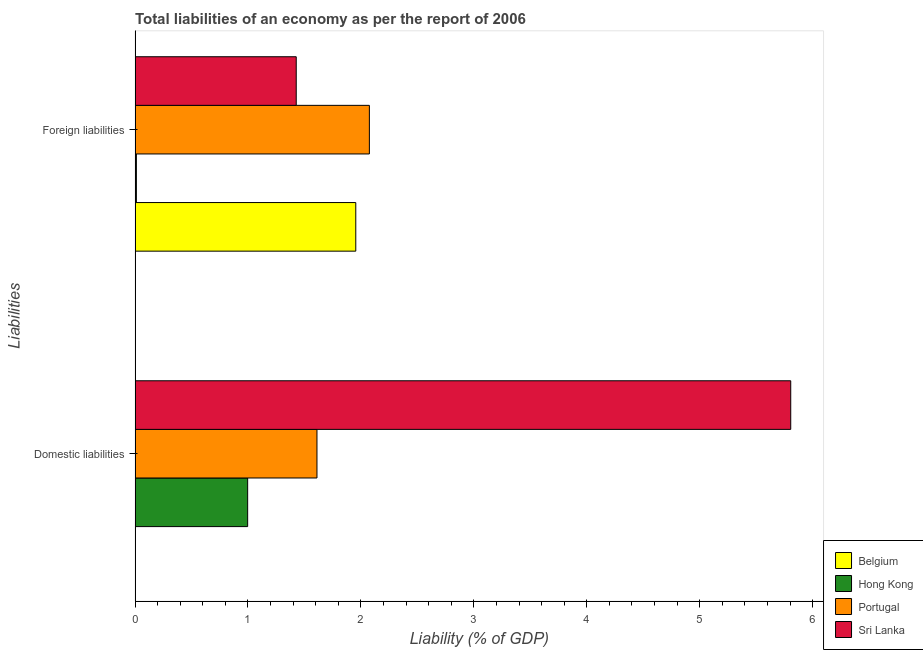How many groups of bars are there?
Provide a succinct answer. 2. Are the number of bars per tick equal to the number of legend labels?
Your answer should be compact. No. Are the number of bars on each tick of the Y-axis equal?
Your response must be concise. No. How many bars are there on the 2nd tick from the bottom?
Give a very brief answer. 4. What is the label of the 1st group of bars from the top?
Provide a short and direct response. Foreign liabilities. What is the incurrence of foreign liabilities in Sri Lanka?
Keep it short and to the point. 1.43. Across all countries, what is the maximum incurrence of domestic liabilities?
Offer a terse response. 5.81. In which country was the incurrence of foreign liabilities maximum?
Make the answer very short. Portugal. What is the total incurrence of foreign liabilities in the graph?
Provide a succinct answer. 5.47. What is the difference between the incurrence of foreign liabilities in Belgium and that in Hong Kong?
Your answer should be compact. 1.94. What is the difference between the incurrence of foreign liabilities in Portugal and the incurrence of domestic liabilities in Belgium?
Give a very brief answer. 2.07. What is the average incurrence of domestic liabilities per country?
Provide a short and direct response. 2.1. What is the difference between the incurrence of domestic liabilities and incurrence of foreign liabilities in Sri Lanka?
Offer a terse response. 4.38. In how many countries, is the incurrence of domestic liabilities greater than 5.2 %?
Offer a terse response. 1. What is the ratio of the incurrence of foreign liabilities in Sri Lanka to that in Hong Kong?
Your answer should be very brief. 123.3. Is the incurrence of foreign liabilities in Belgium less than that in Hong Kong?
Provide a succinct answer. No. What is the difference between two consecutive major ticks on the X-axis?
Provide a short and direct response. 1. Does the graph contain any zero values?
Your answer should be very brief. Yes. How are the legend labels stacked?
Make the answer very short. Vertical. What is the title of the graph?
Offer a terse response. Total liabilities of an economy as per the report of 2006. Does "Tajikistan" appear as one of the legend labels in the graph?
Your answer should be compact. No. What is the label or title of the X-axis?
Offer a very short reply. Liability (% of GDP). What is the label or title of the Y-axis?
Your response must be concise. Liabilities. What is the Liability (% of GDP) of Belgium in Domestic liabilities?
Your answer should be compact. 0. What is the Liability (% of GDP) in Hong Kong in Domestic liabilities?
Ensure brevity in your answer.  1. What is the Liability (% of GDP) of Portugal in Domestic liabilities?
Ensure brevity in your answer.  1.61. What is the Liability (% of GDP) of Sri Lanka in Domestic liabilities?
Provide a succinct answer. 5.81. What is the Liability (% of GDP) in Belgium in Foreign liabilities?
Your answer should be compact. 1.95. What is the Liability (% of GDP) in Hong Kong in Foreign liabilities?
Your answer should be compact. 0.01. What is the Liability (% of GDP) in Portugal in Foreign liabilities?
Provide a succinct answer. 2.07. What is the Liability (% of GDP) in Sri Lanka in Foreign liabilities?
Make the answer very short. 1.43. Across all Liabilities, what is the maximum Liability (% of GDP) of Belgium?
Offer a very short reply. 1.95. Across all Liabilities, what is the maximum Liability (% of GDP) in Hong Kong?
Offer a terse response. 1. Across all Liabilities, what is the maximum Liability (% of GDP) in Portugal?
Offer a very short reply. 2.07. Across all Liabilities, what is the maximum Liability (% of GDP) of Sri Lanka?
Make the answer very short. 5.81. Across all Liabilities, what is the minimum Liability (% of GDP) of Belgium?
Offer a very short reply. 0. Across all Liabilities, what is the minimum Liability (% of GDP) in Hong Kong?
Make the answer very short. 0.01. Across all Liabilities, what is the minimum Liability (% of GDP) of Portugal?
Your answer should be compact. 1.61. Across all Liabilities, what is the minimum Liability (% of GDP) of Sri Lanka?
Keep it short and to the point. 1.43. What is the total Liability (% of GDP) of Belgium in the graph?
Provide a succinct answer. 1.95. What is the total Liability (% of GDP) of Hong Kong in the graph?
Offer a very short reply. 1.01. What is the total Liability (% of GDP) in Portugal in the graph?
Offer a very short reply. 3.69. What is the total Liability (% of GDP) of Sri Lanka in the graph?
Your response must be concise. 7.23. What is the difference between the Liability (% of GDP) in Hong Kong in Domestic liabilities and that in Foreign liabilities?
Provide a short and direct response. 0.99. What is the difference between the Liability (% of GDP) of Portugal in Domestic liabilities and that in Foreign liabilities?
Make the answer very short. -0.46. What is the difference between the Liability (% of GDP) of Sri Lanka in Domestic liabilities and that in Foreign liabilities?
Ensure brevity in your answer.  4.38. What is the difference between the Liability (% of GDP) in Hong Kong in Domestic liabilities and the Liability (% of GDP) in Portugal in Foreign liabilities?
Provide a succinct answer. -1.08. What is the difference between the Liability (% of GDP) of Hong Kong in Domestic liabilities and the Liability (% of GDP) of Sri Lanka in Foreign liabilities?
Your response must be concise. -0.43. What is the difference between the Liability (% of GDP) of Portugal in Domestic liabilities and the Liability (% of GDP) of Sri Lanka in Foreign liabilities?
Keep it short and to the point. 0.18. What is the average Liability (% of GDP) of Belgium per Liabilities?
Keep it short and to the point. 0.98. What is the average Liability (% of GDP) in Hong Kong per Liabilities?
Your answer should be very brief. 0.5. What is the average Liability (% of GDP) of Portugal per Liabilities?
Your answer should be very brief. 1.84. What is the average Liability (% of GDP) in Sri Lanka per Liabilities?
Offer a very short reply. 3.62. What is the difference between the Liability (% of GDP) of Hong Kong and Liability (% of GDP) of Portugal in Domestic liabilities?
Give a very brief answer. -0.61. What is the difference between the Liability (% of GDP) of Hong Kong and Liability (% of GDP) of Sri Lanka in Domestic liabilities?
Give a very brief answer. -4.81. What is the difference between the Liability (% of GDP) of Portugal and Liability (% of GDP) of Sri Lanka in Domestic liabilities?
Your answer should be compact. -4.2. What is the difference between the Liability (% of GDP) in Belgium and Liability (% of GDP) in Hong Kong in Foreign liabilities?
Give a very brief answer. 1.94. What is the difference between the Liability (% of GDP) in Belgium and Liability (% of GDP) in Portugal in Foreign liabilities?
Your answer should be compact. -0.12. What is the difference between the Liability (% of GDP) in Belgium and Liability (% of GDP) in Sri Lanka in Foreign liabilities?
Offer a terse response. 0.53. What is the difference between the Liability (% of GDP) of Hong Kong and Liability (% of GDP) of Portugal in Foreign liabilities?
Your response must be concise. -2.06. What is the difference between the Liability (% of GDP) of Hong Kong and Liability (% of GDP) of Sri Lanka in Foreign liabilities?
Your answer should be very brief. -1.42. What is the difference between the Liability (% of GDP) of Portugal and Liability (% of GDP) of Sri Lanka in Foreign liabilities?
Offer a terse response. 0.65. What is the ratio of the Liability (% of GDP) of Hong Kong in Domestic liabilities to that in Foreign liabilities?
Offer a terse response. 86.14. What is the ratio of the Liability (% of GDP) of Portugal in Domestic liabilities to that in Foreign liabilities?
Give a very brief answer. 0.78. What is the ratio of the Liability (% of GDP) in Sri Lanka in Domestic liabilities to that in Foreign liabilities?
Make the answer very short. 4.07. What is the difference between the highest and the second highest Liability (% of GDP) of Hong Kong?
Provide a succinct answer. 0.99. What is the difference between the highest and the second highest Liability (% of GDP) in Portugal?
Provide a short and direct response. 0.46. What is the difference between the highest and the second highest Liability (% of GDP) in Sri Lanka?
Provide a succinct answer. 4.38. What is the difference between the highest and the lowest Liability (% of GDP) of Belgium?
Give a very brief answer. 1.95. What is the difference between the highest and the lowest Liability (% of GDP) of Hong Kong?
Your response must be concise. 0.99. What is the difference between the highest and the lowest Liability (% of GDP) in Portugal?
Make the answer very short. 0.46. What is the difference between the highest and the lowest Liability (% of GDP) in Sri Lanka?
Offer a very short reply. 4.38. 